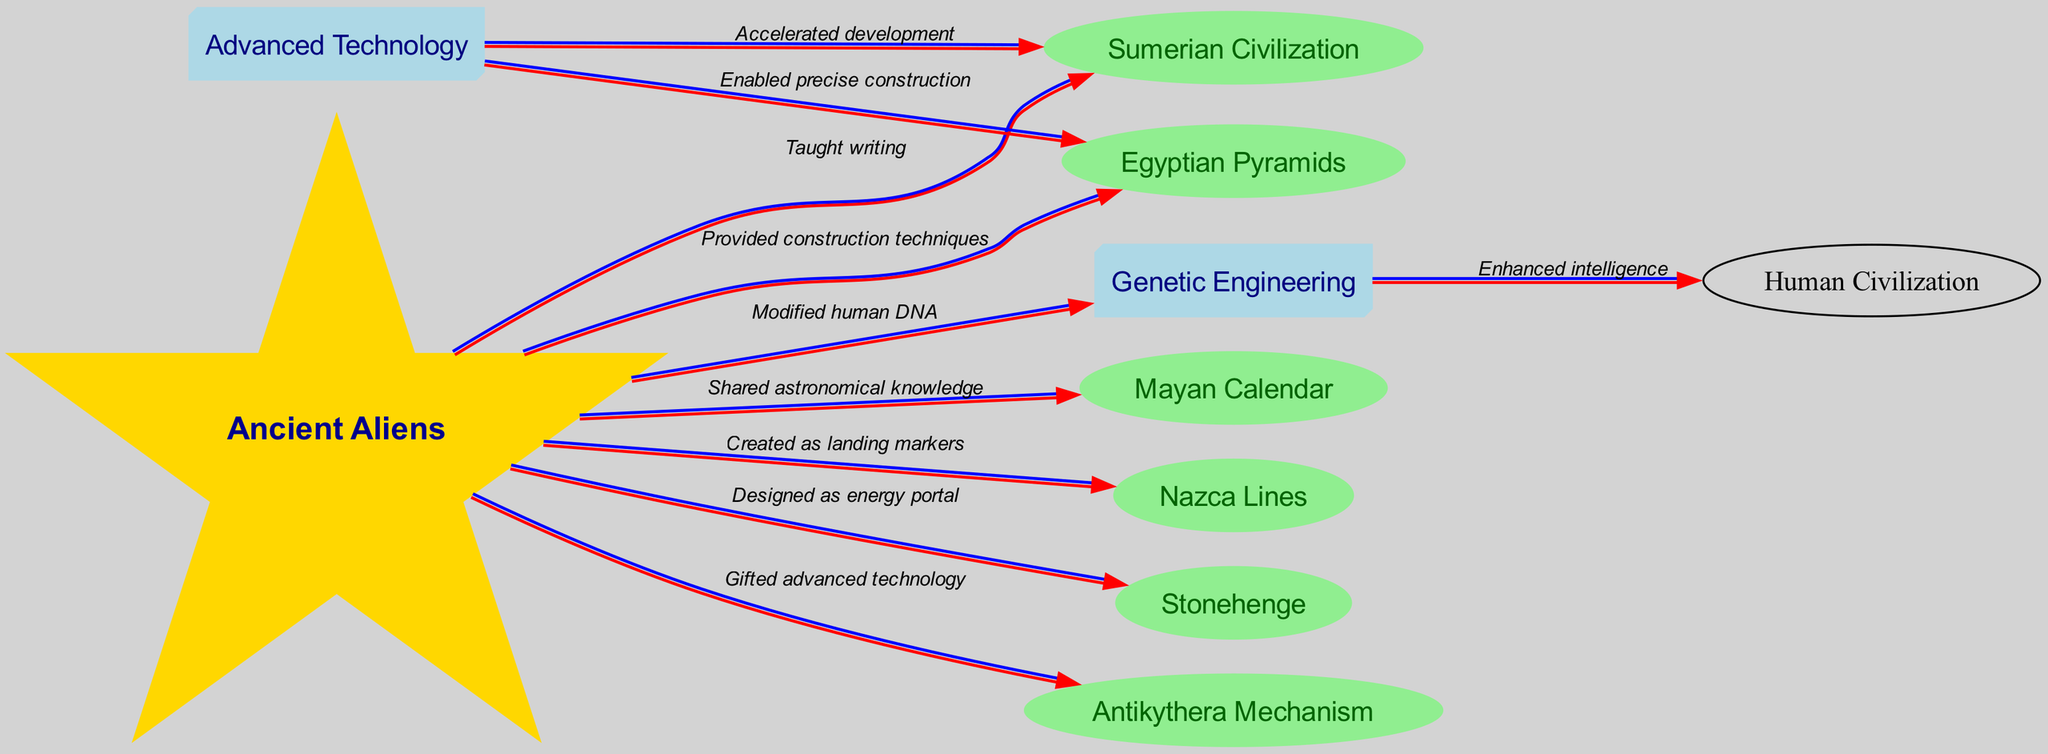What is the total number of nodes in the diagram? The diagram lists eight unique entities or concepts as nodes: Ancient Aliens, Sumerian Civilization, Egyptian Pyramids, Mayan Calendar, Nazca Lines, Stonehenge, Antikythera Mechanism, and Genetic Engineering. Counting all these gives a total of eight nodes.
Answer: 8 Which civilization is connected to Genetic Engineering? The diagram shows an edge directed from Genetic Engineering to Human Civilization, indicating a connection. The relationship is noted as "Enhanced intelligence."
Answer: Human Civilization What is the relationship between Ancient Aliens and the Egyptian Pyramids? The diagram depicts a directed edge from Ancient Aliens to Egyptian Pyramids, labeled "Provided construction techniques." This indicates that according to the diagram, Ancient Aliens influenced the construction methods used for the Egyptian Pyramids.
Answer: Provided construction techniques How many edges are in the diagram? The diagram contains eight edges, which represent the directed relationships between the nodes. Each relationship is established via an arrow (edge) connecting two nodes (entities).
Answer: 8 What type of node is Ancient Aliens? In the diagram, Ancient Aliens is represented as a star-shaped node with unique styling different from the other nodes, which are either ellipse or box3d. This signifies its importance in the context of this conspiracy theory.
Answer: Star What knowledge did Ancient Aliens share with the Mayans? The edge from Ancient Aliens to the Mayan Calendar indicates the relationship is labeled "Shared astronomical knowledge." This suggests that Ancient Aliens provided the Mayans with information regarding astronomical observations and calculations.
Answer: Shared astronomical knowledge Which advanced technology is connected to the Sumerian Civilization? The directed edge from Advanced Technology to Sumerian Civilization indicates an influence of advanced technology on the development of the Sumerian Civilization, marked as "Accelerated development."
Answer: Accelerated development What is the significance of the Nazca Lines according to this diagram? The diagram indicates that Nazca Lines were "Created as landing markers," which implies they had a specific purpose related to Ancient Aliens' visitations, suggesting they were used for guidance by alien spacecraft.
Answer: Created as landing markers What type of shape is used to represent Genetic Engineering in the diagram? Genetic Engineering is represented as a box3d shape in the diagram. This type of shape is utilized to signify technology-related nodes in the visual representation.
Answer: Box3d 